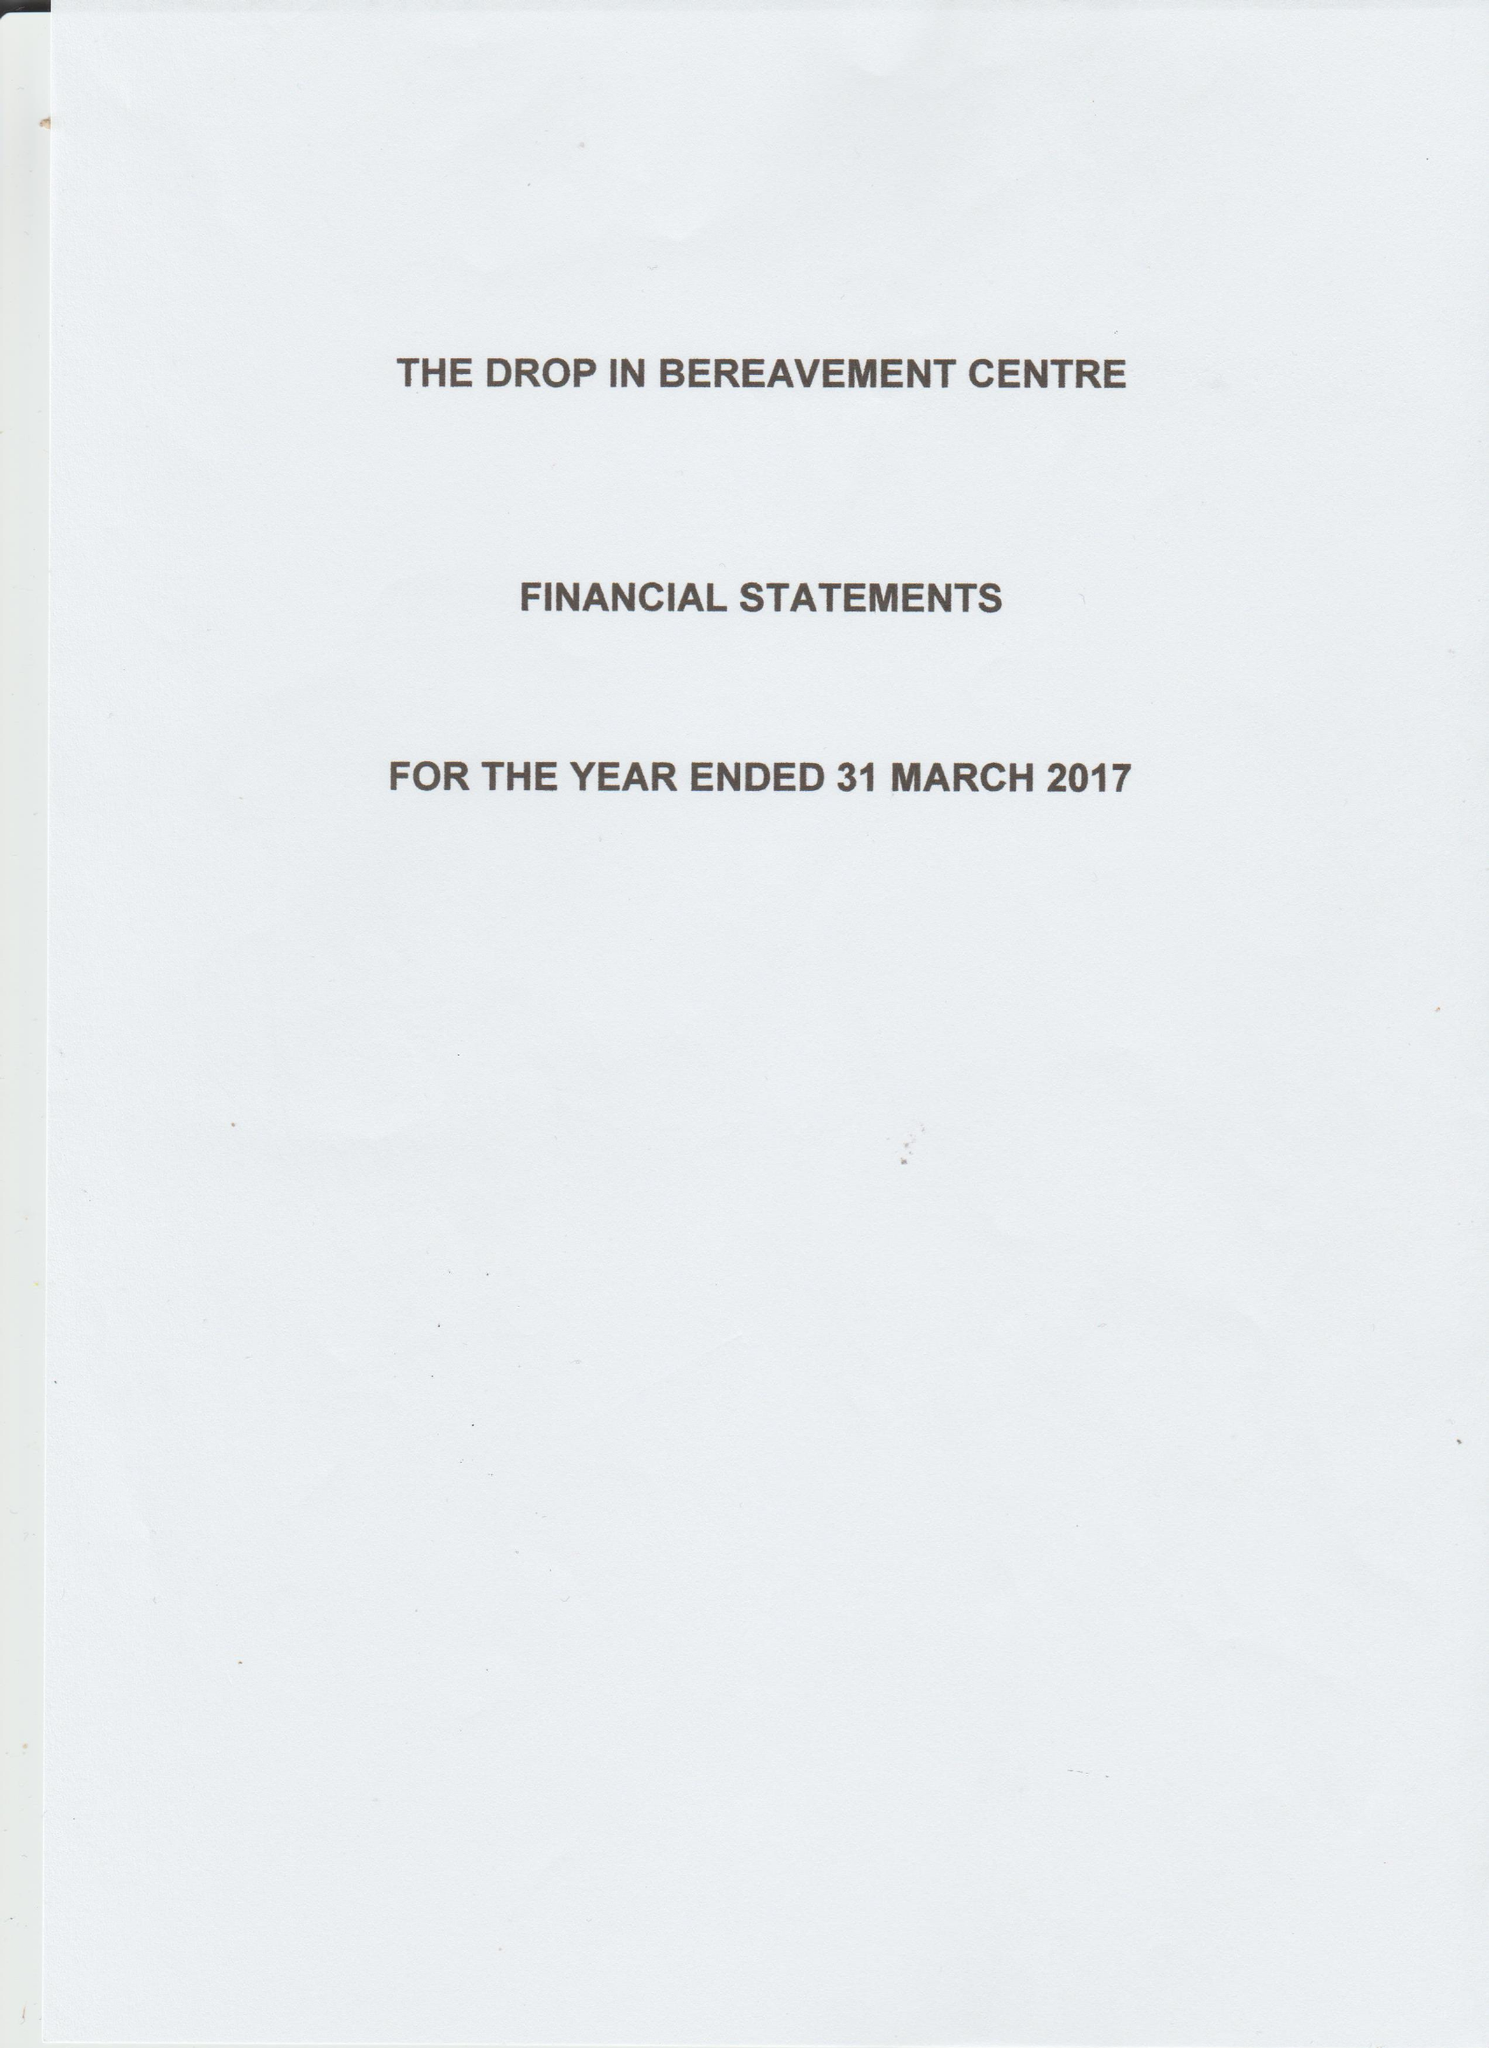What is the value for the report_date?
Answer the question using a single word or phrase. 2017-03-31 